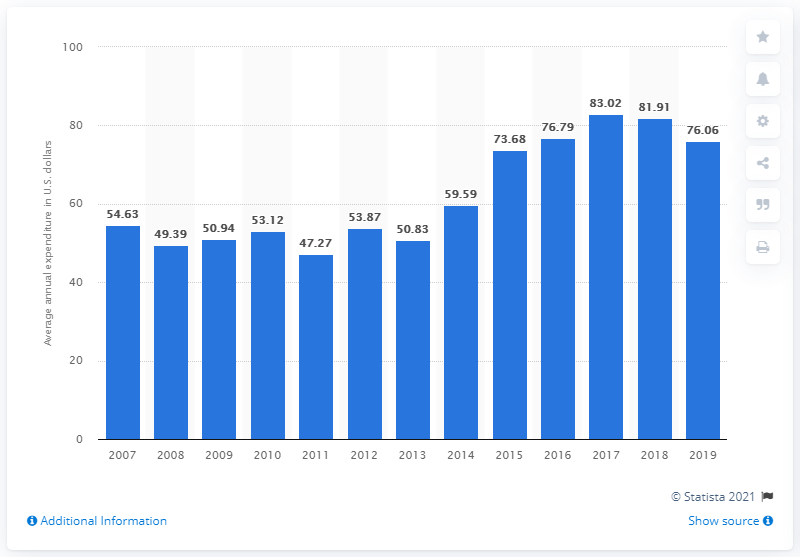Draw attention to some important aspects in this diagram. According to data from 2019, the average expenditure on refrigerators and freezers per consumer unit in the United States was approximately $76.06. 